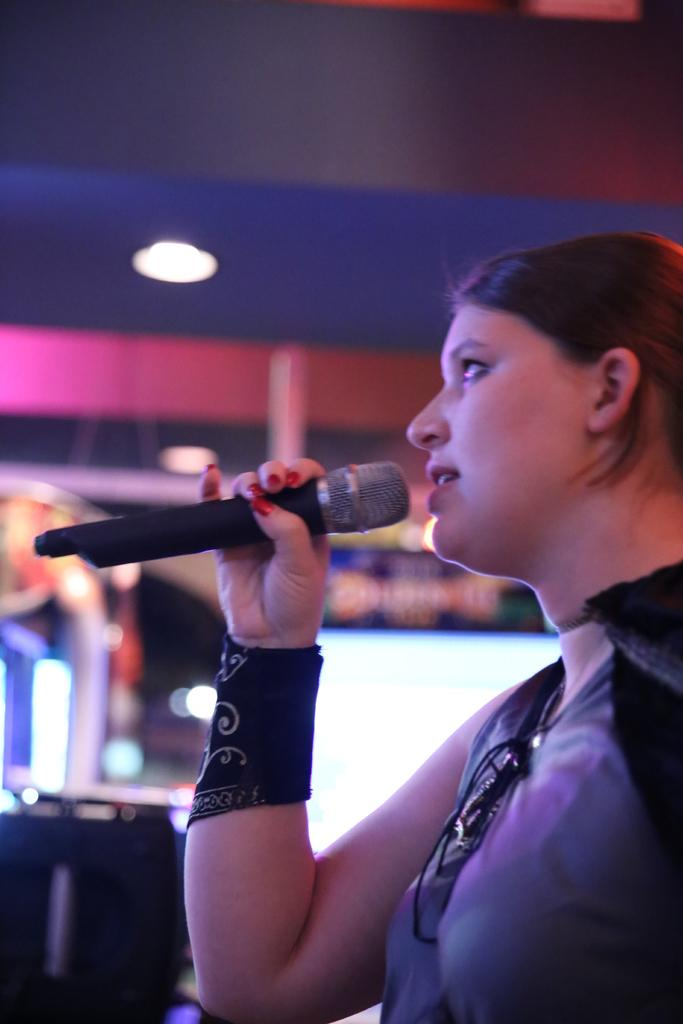Who is the main subject in the image? There is a woman in the image. What is the woman holding in her hand? The woman is holding a microphone in her hand. What type of desk is visible in the image? There is no desk present in the image. What scientific theory is the woman discussing while holding the microphone? The image does not provide any information about the woman discussing a scientific theory. 